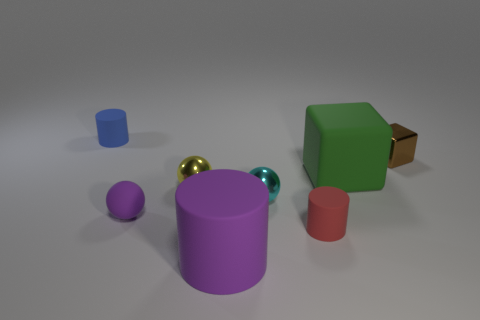How many objects are behind the tiny brown cube and in front of the small cyan metallic thing?
Provide a succinct answer. 0. How many other things are the same color as the tiny matte sphere?
Your response must be concise. 1. What number of cyan things are large cubes or cubes?
Provide a succinct answer. 0. The blue rubber cylinder has what size?
Make the answer very short. Small. How many matte objects are brown things or big green cylinders?
Give a very brief answer. 0. Is the number of small rubber spheres less than the number of purple matte objects?
Your answer should be compact. Yes. What number of other objects are there of the same material as the yellow ball?
Make the answer very short. 2. The purple object that is the same shape as the small cyan object is what size?
Your response must be concise. Small. Do the small cylinder on the right side of the large matte cylinder and the thing that is to the right of the large green thing have the same material?
Keep it short and to the point. No. Is the number of small cyan metallic balls behind the brown metallic cube less than the number of cyan things?
Your response must be concise. Yes. 